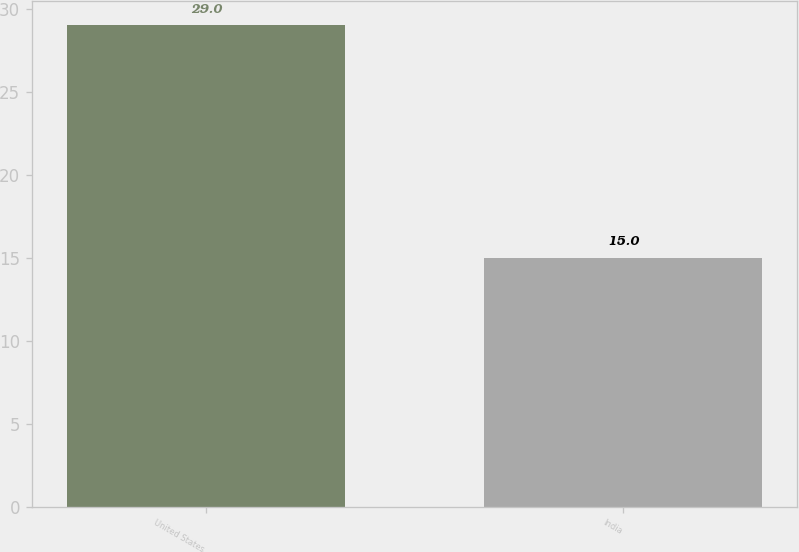Convert chart to OTSL. <chart><loc_0><loc_0><loc_500><loc_500><bar_chart><fcel>United States<fcel>India<nl><fcel>29<fcel>15<nl></chart> 